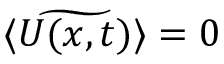<formula> <loc_0><loc_0><loc_500><loc_500>\langle \widetilde { U ( x , t ) } \rangle = 0</formula> 